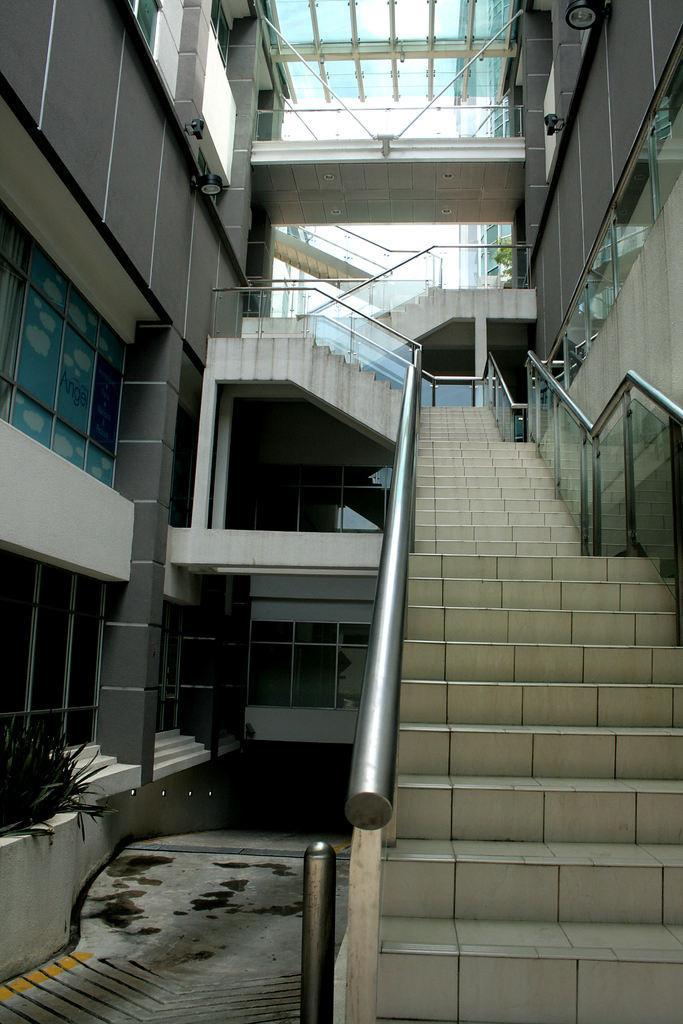Could you give a brief overview of what you see in this image? In this picture we can see a building and rods. 